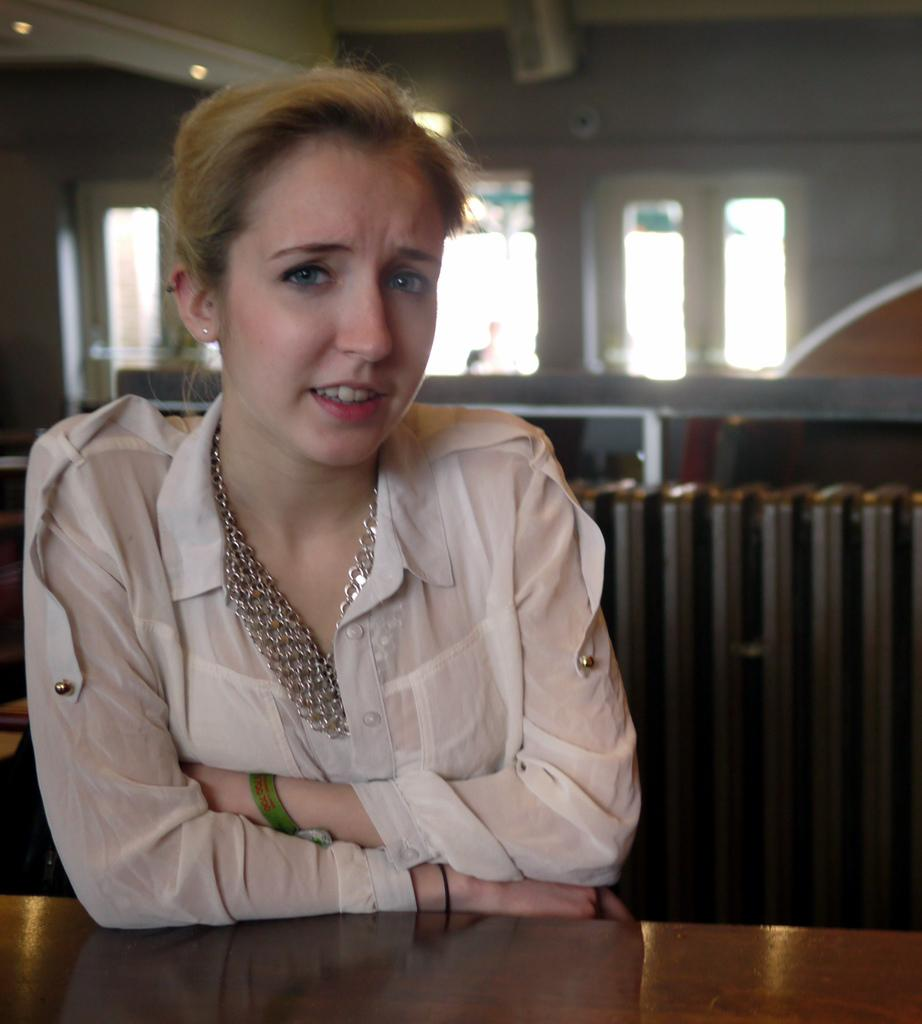Who is present in the image? There is a woman in the image. What is the woman wearing? The woman is wearing a white dress. What can be seen in the background of the image? There is a wall and windows in the background of the image. What is the value of the gold bee in the image? There is no gold bee present in the image, so it is not possible to determine its value. 